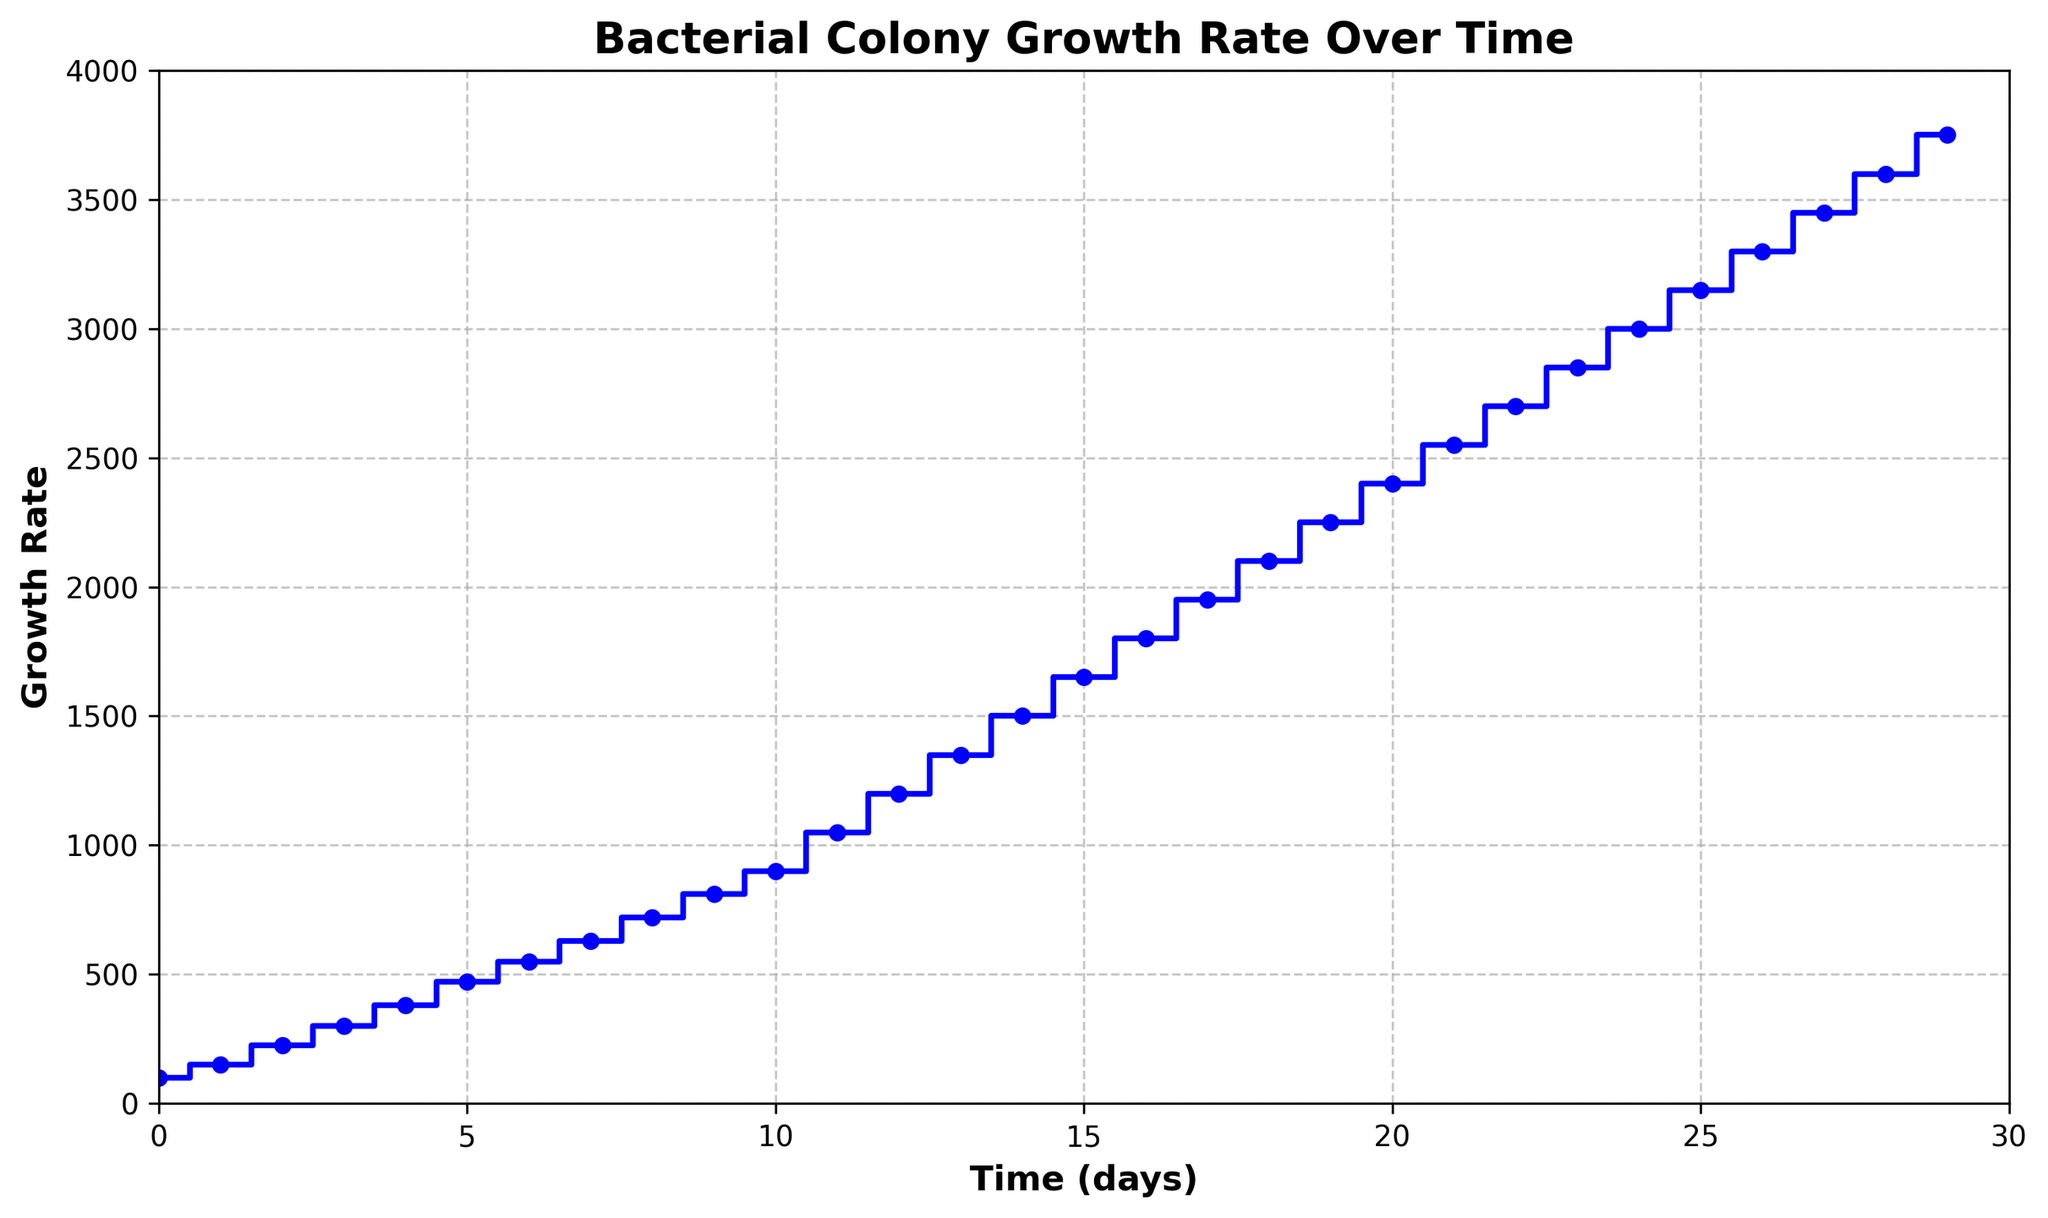What is the growth rate at day 10? The graph shows a step at day 10 aligned with the value on the y-axis. The height of this step indicates the bacterial colony's growth rate.
Answer: 900 At what time point does the growth rate exceed 1500? Evaluate when the steps on the graph cross above the 1500 mark on the y-axis. The first time this happens is at day 14.
Answer: Day 14 On which day is the growth rate exactly 1050? Identify the step corresponding to 1050 on the y-axis and trace it back to the x-axis. The figure shows that day 11 has a growth rate of 1050.
Answer: Day 11 How much does the growth rate increase from day 5 to day 10? The growth rate at day 5 is 470, and at day 10, it's 900. To find the increase: 900 - 470 = 430.
Answer: 430 What is the average growth rate over the first 5 days? Add the growth rates for days 0 to 5 (100, 150, 225, 300, 380) and divide by 6 to get the average: (100 + 150 + 225 + 300 + 380 + 470) / 6 = 1625 / 6 ≈ 270.83.
Answer: 270.83 When does the bacterial growth rate first reach or exceed 2100? Find the first step reaching 2100 on the y-axis and trace it to the x-axis. This occurs at day 18.
Answer: Day 18 By what amount does the growth rate increase from one day to the next on average? Calculate the average of the daily increments. First find the total increase from day 0 to day 29, which is 3750 - 100 = 3650. Then divide by the number of days, 29. So, the average daily increase is 3650 / 29 ≈ 125.86.
Answer: 125.86 How does the growth rate on day 20 compare to the growth rate on day 25? Find where the stairs align with the y-axis on these days. The rate on day 20 is 2400, and on day 25, it is 3150. The growth rate at day 25 is higher.
Answer: Day 25 > Day 20 By what percentage does the growth rate increase from day 0 to day 5? The rate at day 0 is 100, and at day 5, it's 470. Use the formula ((New - Old) / Old) * 100 to find the percentage increase: ((470 - 100) / 100) * 100 = 370%.
Answer: 370% How many days does it take for the growth rate to double from its initial value? The initial value is 100. Double this is 200. The growth rate first exceeds 200 on day 2.
Answer: 2 days 